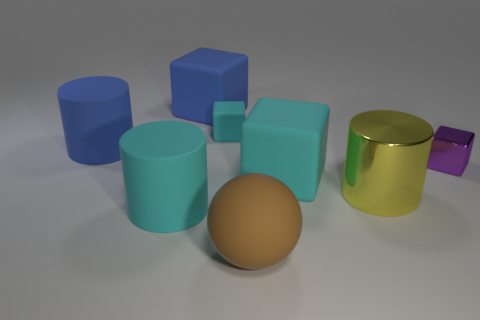How many yellow rubber objects are the same size as the blue cylinder?
Provide a short and direct response. 0. The big object that is to the right of the big brown rubber thing and left of the yellow metal cylinder is what color?
Offer a very short reply. Cyan. Are there fewer large yellow things than small gray cubes?
Provide a succinct answer. No. There is a small rubber thing; is it the same color as the large matte cylinder that is in front of the large shiny cylinder?
Provide a short and direct response. Yes. Are there an equal number of big cyan objects that are right of the small purple block and cylinders behind the big cyan rubber cylinder?
Keep it short and to the point. No. How many large blue things are the same shape as the tiny metallic object?
Make the answer very short. 1. Is there a green cylinder?
Provide a succinct answer. No. Is the material of the yellow cylinder the same as the cyan thing that is behind the small purple metallic object?
Offer a very short reply. No. What material is the cyan block that is the same size as the purple metallic thing?
Provide a succinct answer. Rubber. Are there any tiny cubes made of the same material as the big yellow thing?
Provide a succinct answer. Yes. 